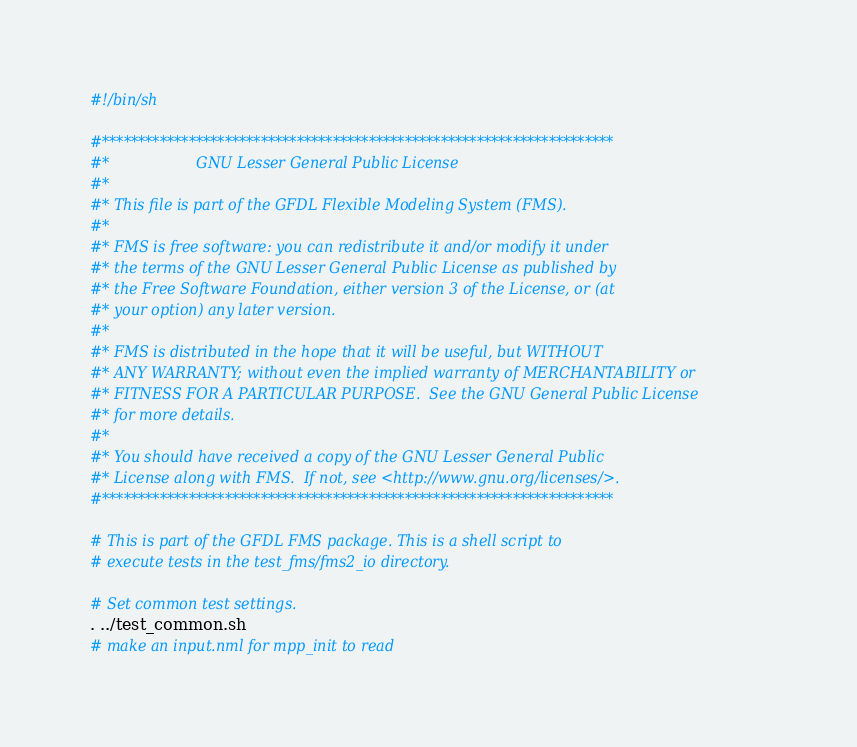<code> <loc_0><loc_0><loc_500><loc_500><_Bash_>#!/bin/sh

#***********************************************************************
#*                   GNU Lesser General Public License
#*
#* This file is part of the GFDL Flexible Modeling System (FMS).
#*
#* FMS is free software: you can redistribute it and/or modify it under
#* the terms of the GNU Lesser General Public License as published by
#* the Free Software Foundation, either version 3 of the License, or (at
#* your option) any later version.
#*
#* FMS is distributed in the hope that it will be useful, but WITHOUT
#* ANY WARRANTY; without even the implied warranty of MERCHANTABILITY or
#* FITNESS FOR A PARTICULAR PURPOSE.  See the GNU General Public License
#* for more details.
#*
#* You should have received a copy of the GNU Lesser General Public
#* License along with FMS.  If not, see <http://www.gnu.org/licenses/>.
#***********************************************************************

# This is part of the GFDL FMS package. This is a shell script to
# execute tests in the test_fms/fms2_io directory.

# Set common test settings.
. ../test_common.sh
# make an input.nml for mpp_init to read</code> 